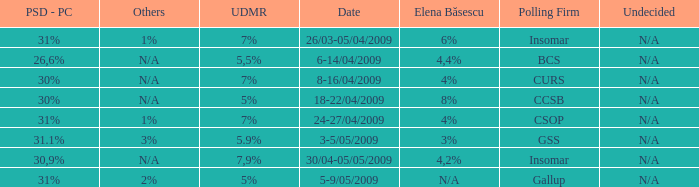What date has the others of 2%? 5-9/05/2009. 